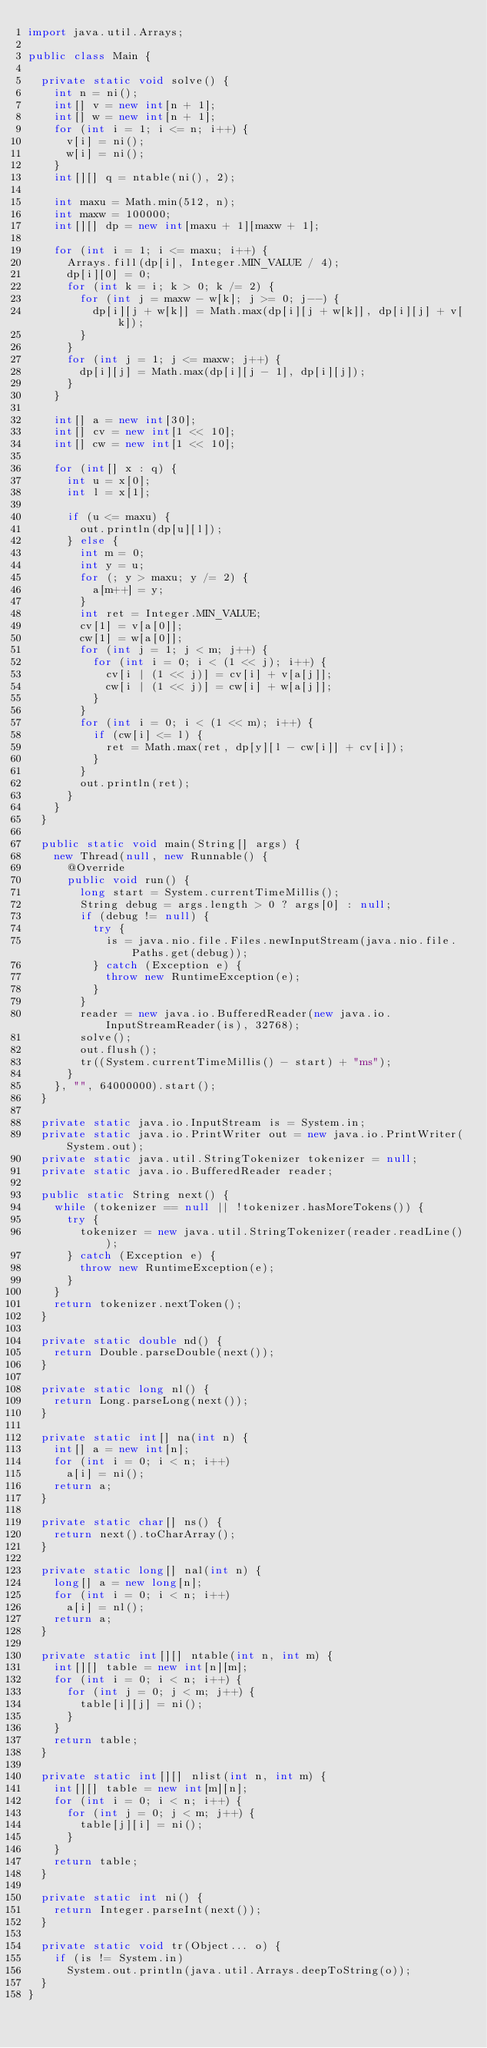Convert code to text. <code><loc_0><loc_0><loc_500><loc_500><_Java_>import java.util.Arrays;

public class Main {

  private static void solve() {
    int n = ni();
    int[] v = new int[n + 1];
    int[] w = new int[n + 1];
    for (int i = 1; i <= n; i++) {
      v[i] = ni();
      w[i] = ni();
    }
    int[][] q = ntable(ni(), 2);

    int maxu = Math.min(512, n);
    int maxw = 100000;
    int[][] dp = new int[maxu + 1][maxw + 1];

    for (int i = 1; i <= maxu; i++) {
      Arrays.fill(dp[i], Integer.MIN_VALUE / 4);
      dp[i][0] = 0;
      for (int k = i; k > 0; k /= 2) {
        for (int j = maxw - w[k]; j >= 0; j--) {
          dp[i][j + w[k]] = Math.max(dp[i][j + w[k]], dp[i][j] + v[k]);
        }
      }
      for (int j = 1; j <= maxw; j++) {
        dp[i][j] = Math.max(dp[i][j - 1], dp[i][j]);
      }
    }

    int[] a = new int[30];
    int[] cv = new int[1 << 10];
    int[] cw = new int[1 << 10];

    for (int[] x : q) {
      int u = x[0];
      int l = x[1];

      if (u <= maxu) {
        out.println(dp[u][l]);
      } else {
        int m = 0;
        int y = u;
        for (; y > maxu; y /= 2) {
          a[m++] = y;
        }
        int ret = Integer.MIN_VALUE;
        cv[1] = v[a[0]];
        cw[1] = w[a[0]];
        for (int j = 1; j < m; j++) {
          for (int i = 0; i < (1 << j); i++) {
            cv[i | (1 << j)] = cv[i] + v[a[j]];
            cw[i | (1 << j)] = cw[i] + w[a[j]];
          }
        }
        for (int i = 0; i < (1 << m); i++) {
          if (cw[i] <= l) {
            ret = Math.max(ret, dp[y][l - cw[i]] + cv[i]);
          }
        }
        out.println(ret);
      }
    }
  }

  public static void main(String[] args) {
    new Thread(null, new Runnable() {
      @Override
      public void run() {
        long start = System.currentTimeMillis();
        String debug = args.length > 0 ? args[0] : null;
        if (debug != null) {
          try {
            is = java.nio.file.Files.newInputStream(java.nio.file.Paths.get(debug));
          } catch (Exception e) {
            throw new RuntimeException(e);
          }
        }
        reader = new java.io.BufferedReader(new java.io.InputStreamReader(is), 32768);
        solve();
        out.flush();
        tr((System.currentTimeMillis() - start) + "ms");
      }
    }, "", 64000000).start();
  }

  private static java.io.InputStream is = System.in;
  private static java.io.PrintWriter out = new java.io.PrintWriter(System.out);
  private static java.util.StringTokenizer tokenizer = null;
  private static java.io.BufferedReader reader;

  public static String next() {
    while (tokenizer == null || !tokenizer.hasMoreTokens()) {
      try {
        tokenizer = new java.util.StringTokenizer(reader.readLine());
      } catch (Exception e) {
        throw new RuntimeException(e);
      }
    }
    return tokenizer.nextToken();
  }

  private static double nd() {
    return Double.parseDouble(next());
  }

  private static long nl() {
    return Long.parseLong(next());
  }

  private static int[] na(int n) {
    int[] a = new int[n];
    for (int i = 0; i < n; i++)
      a[i] = ni();
    return a;
  }

  private static char[] ns() {
    return next().toCharArray();
  }

  private static long[] nal(int n) {
    long[] a = new long[n];
    for (int i = 0; i < n; i++)
      a[i] = nl();
    return a;
  }

  private static int[][] ntable(int n, int m) {
    int[][] table = new int[n][m];
    for (int i = 0; i < n; i++) {
      for (int j = 0; j < m; j++) {
        table[i][j] = ni();
      }
    }
    return table;
  }

  private static int[][] nlist(int n, int m) {
    int[][] table = new int[m][n];
    for (int i = 0; i < n; i++) {
      for (int j = 0; j < m; j++) {
        table[j][i] = ni();
      }
    }
    return table;
  }

  private static int ni() {
    return Integer.parseInt(next());
  }

  private static void tr(Object... o) {
    if (is != System.in)
      System.out.println(java.util.Arrays.deepToString(o));
  }
}
</code> 